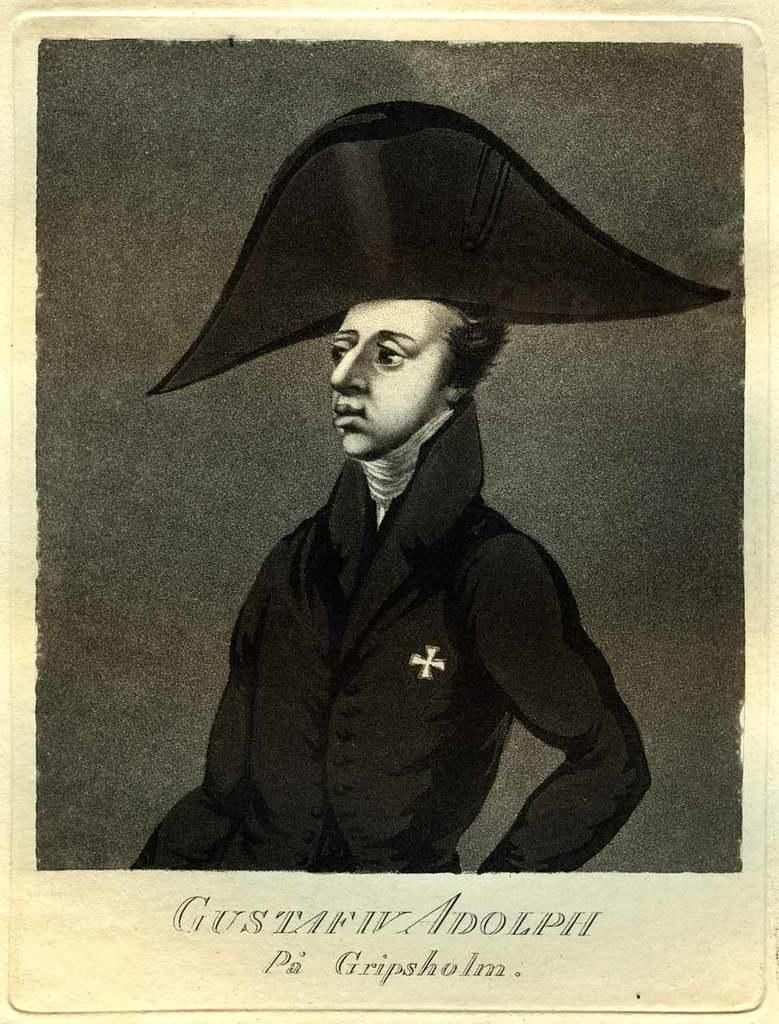What is the main subject of the image? There is a photograph of a person in the image. Can you describe any additional elements in the image? There is text at the bottom of the image. What type of haircut does the person have in the image? The provided facts do not mention the person's haircut, so it cannot be determined from the image. 